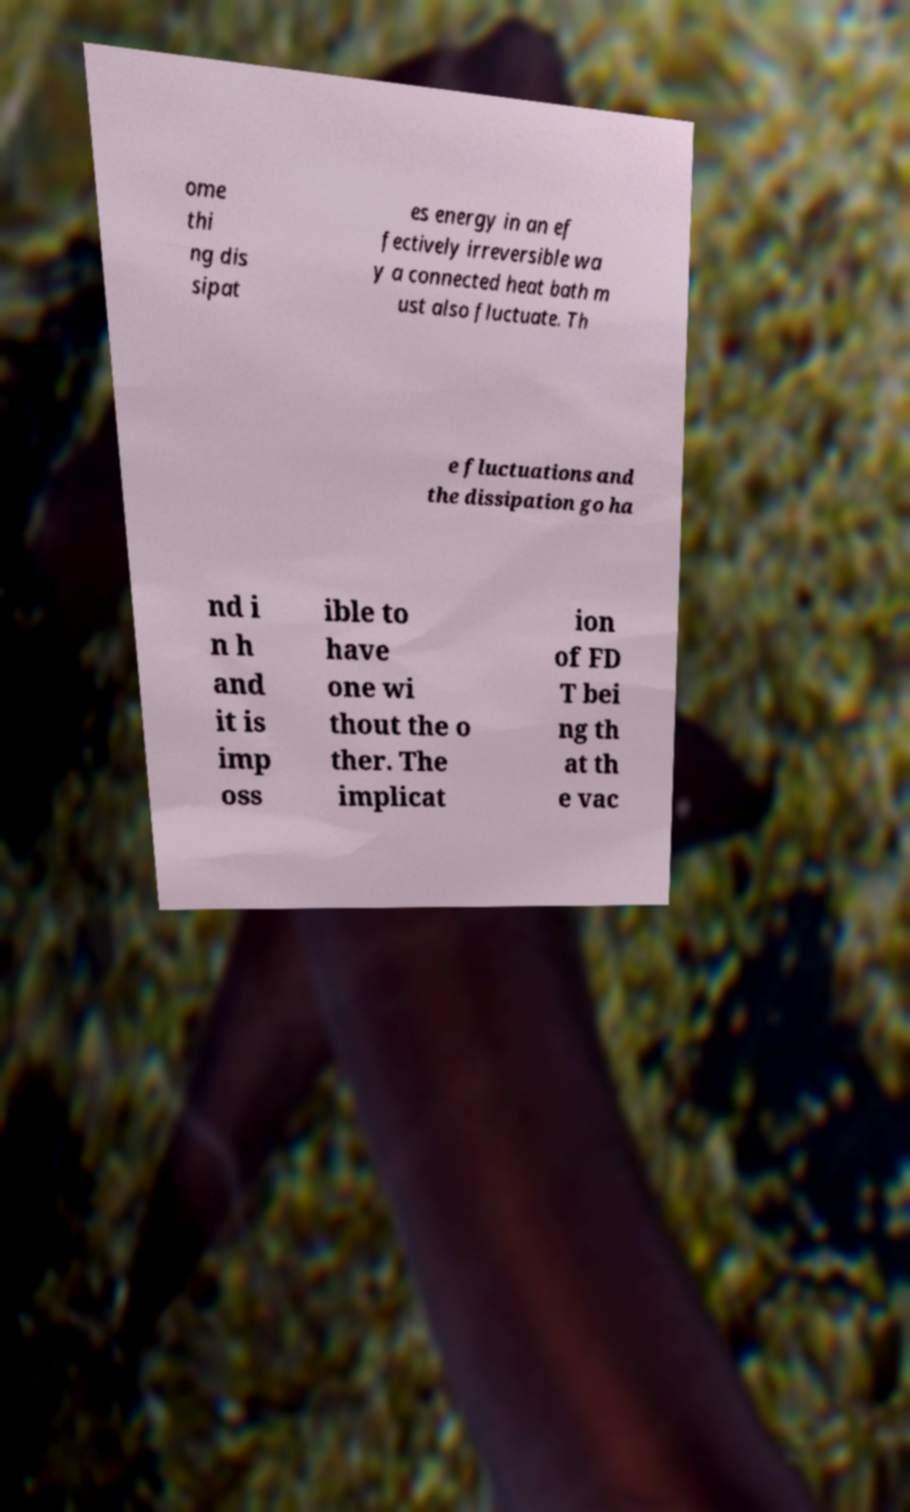Can you accurately transcribe the text from the provided image for me? ome thi ng dis sipat es energy in an ef fectively irreversible wa y a connected heat bath m ust also fluctuate. Th e fluctuations and the dissipation go ha nd i n h and it is imp oss ible to have one wi thout the o ther. The implicat ion of FD T bei ng th at th e vac 